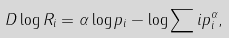Convert formula to latex. <formula><loc_0><loc_0><loc_500><loc_500>D \log R _ { i } = \alpha \log p _ { i } - \log \sum i p _ { i } ^ { \alpha } ,</formula> 